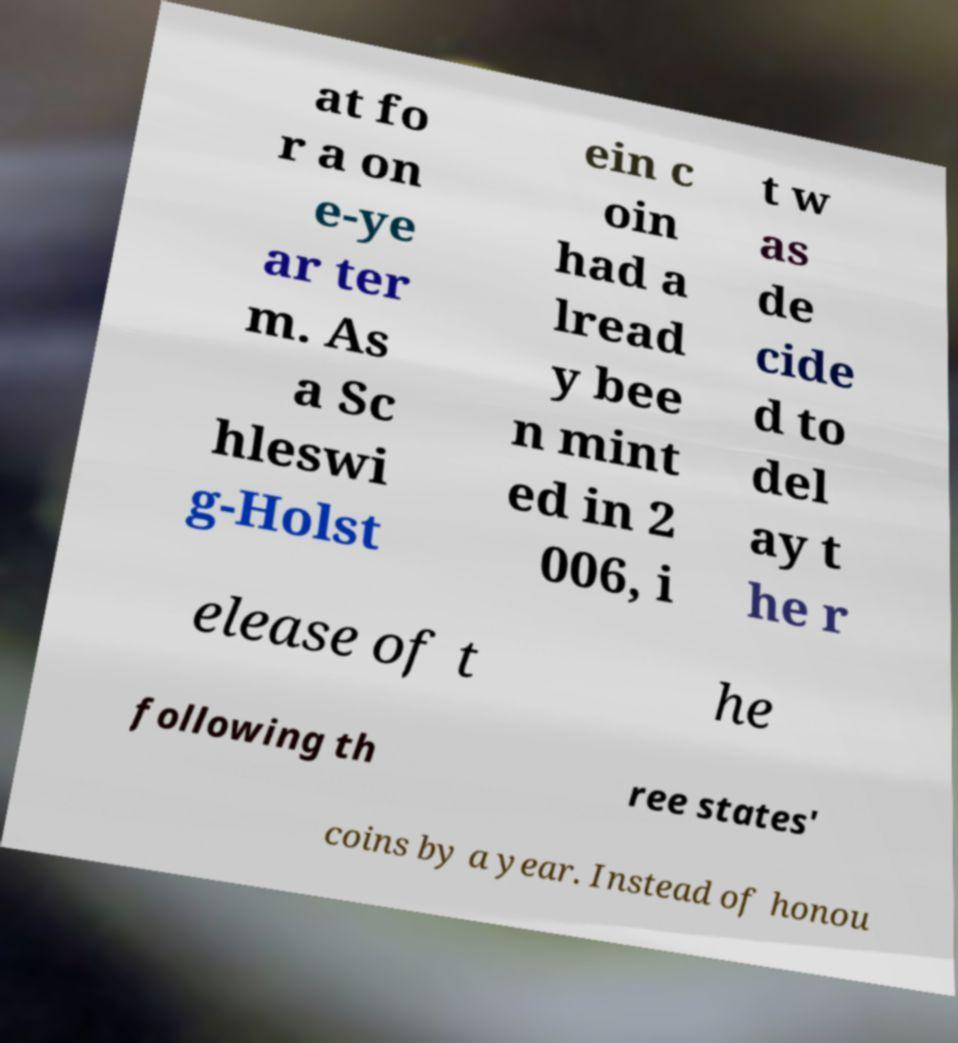Can you accurately transcribe the text from the provided image for me? at fo r a on e-ye ar ter m. As a Sc hleswi g-Holst ein c oin had a lread y bee n mint ed in 2 006, i t w as de cide d to del ay t he r elease of t he following th ree states' coins by a year. Instead of honou 